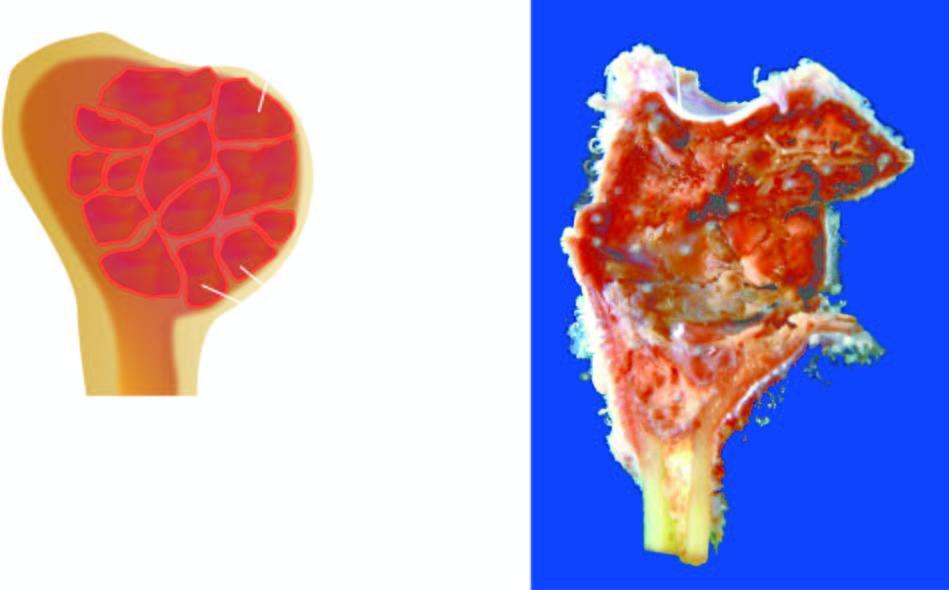what is expanded due to a cyst?
Answer the question using a single word or phrase. End of the long bone 